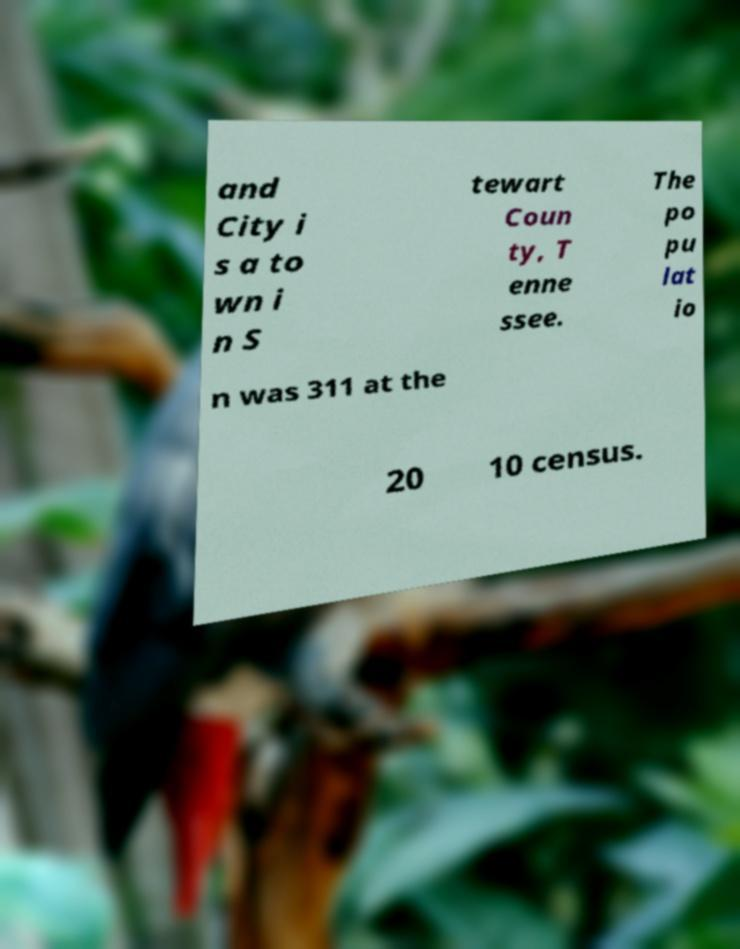Please identify and transcribe the text found in this image. and City i s a to wn i n S tewart Coun ty, T enne ssee. The po pu lat io n was 311 at the 20 10 census. 